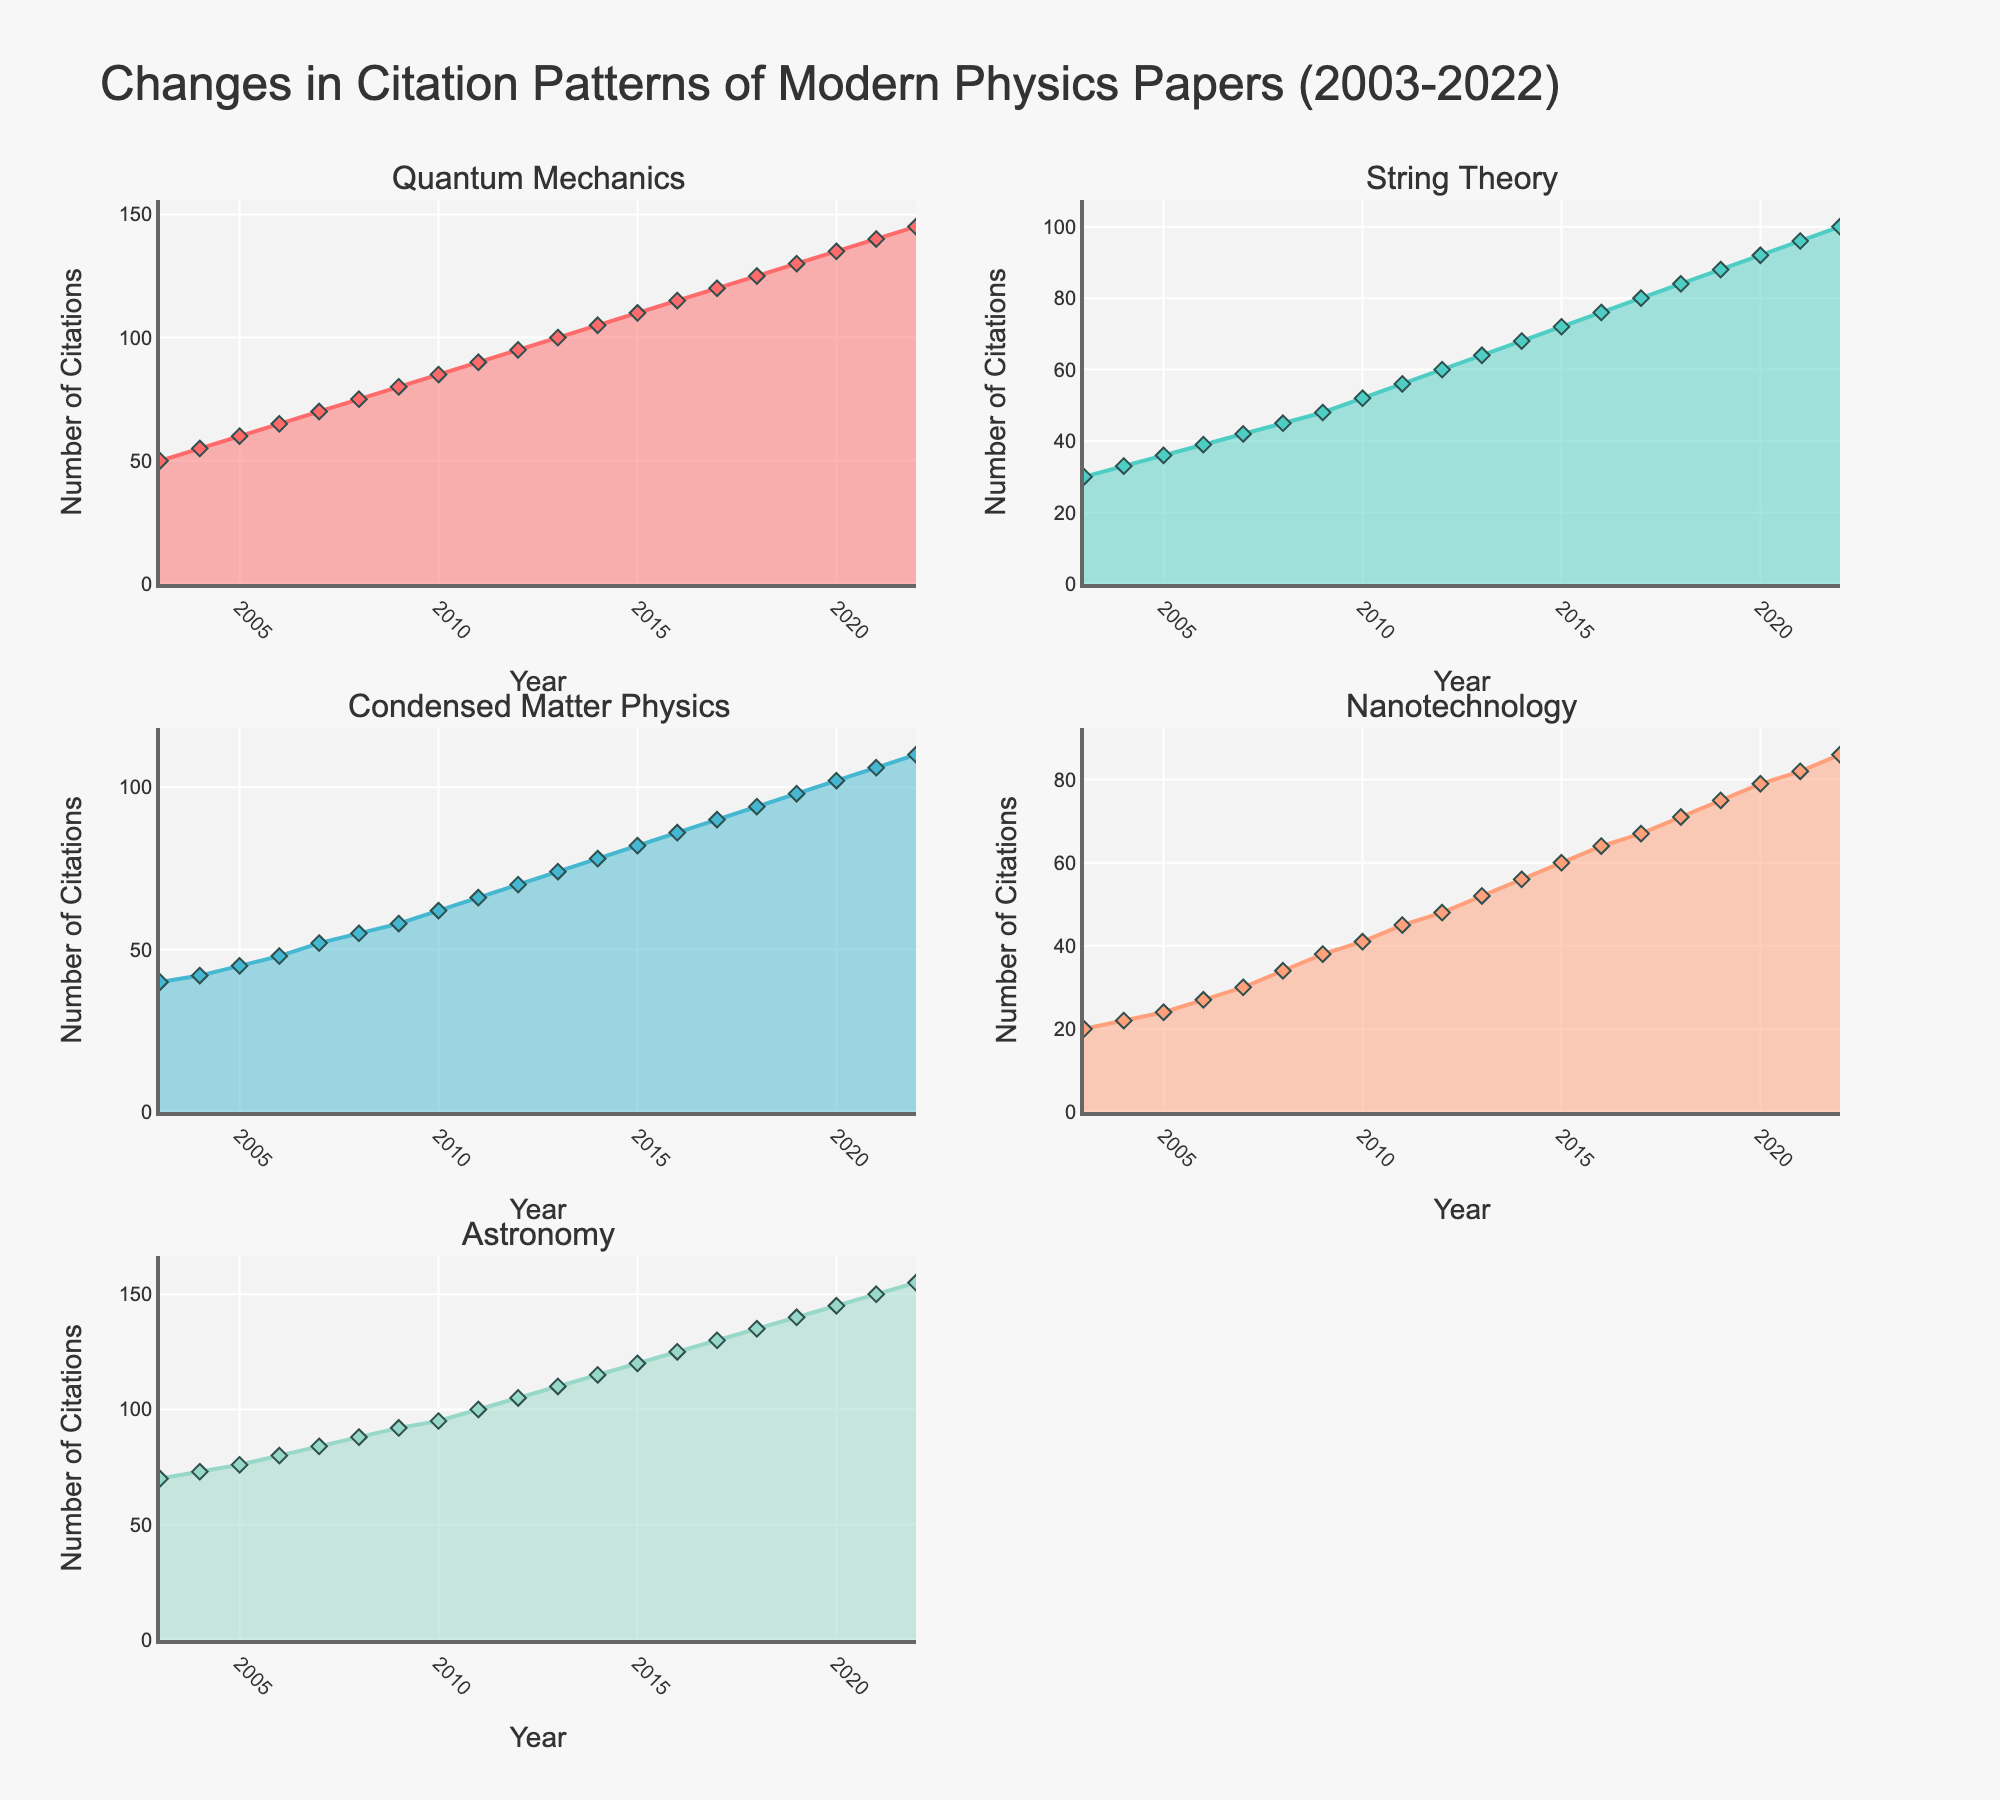What is the title of the figure? The title is usually placed at the top of the figure. In this case, the title is "Changes in Citation Patterns of Modern Physics Papers (2003-2022)".
Answer: Changes in Citation Patterns of Modern Physics Papers (2003-2022) What are the sub-fields whose citation patterns are plotted in this figure? The subplot titles list the sub-fields. These sub-fields are Quantum Mechanics, String Theory, Condensed Matter Physics, Nanotechnology, and Astronomy.
Answer: Quantum Mechanics, String Theory, Condensed Matter Physics, Nanotechnology, Astronomy Which sub-field has the highest number of citations in 2022? Check the end of each subplot's graph for the year 2022. The sub-field with the highest value on the y-axis for 2022 is Astronomy.
Answer: Astronomy In what year did String Theory surpass 50 citations? Look at the subplot for String Theory and identify the year when the citations first exceed 50. This occurred in 2010.
Answer: 2010 Calculate the total number of citations for Quantum Mechanics and String Theory in 2015. Find the 2015 data points for Quantum Mechanics and String Theory from their respective subplots. Quantum Mechanics has 110 citations, and String Theory has 72. Summing these gives 110 + 72 = 182.
Answer: 182 Which sub-field shows the most rapid increase in citations over the 20-year period? Analyze the slopes of the areas in each subplot. The subplot with the steepest slope indicates the most rapid increase. Quantum Mechanics shows the steepest increase.
Answer: Quantum Mechanics How many years did it take for Nanotechnology citations to double from 2003 levels? Identify the citation count for Nanotechnology in 2003 (20 citations) and then find the year when it first reaches 40 citations. This happens in 2008. Thus, it took 2008 - 2003 = 5 years.
Answer: 5 years Compare the increase in citations from 2003 to 2022 between Quantum Mechanics and Condensed Matter Physics. Which had a greater absolute increase, and by how much? Calculate the difference in citations from 2022 to 2003 for both sub-fields. Quantum Mechanics increased from 50 to 145 (145 - 50 = 95). Condensed Matter Physics increased from 40 to 110 (110 - 40 = 70). Quantum Mechanics had a greater increase by 95 - 70 = 25.
Answer: Quantum Mechanics by 25 Determine the average citation increase per year for Nanotechnology from 2003 to 2022. Calculate the total increase over the period by subtracting the 2003 value from the 2022 value (86 - 20 = 66) and then divide by the number of years (2022 - 2003 = 19). Average increase per year is 66 / 19 ≈ 3.47.
Answer: ≈ 3.47 